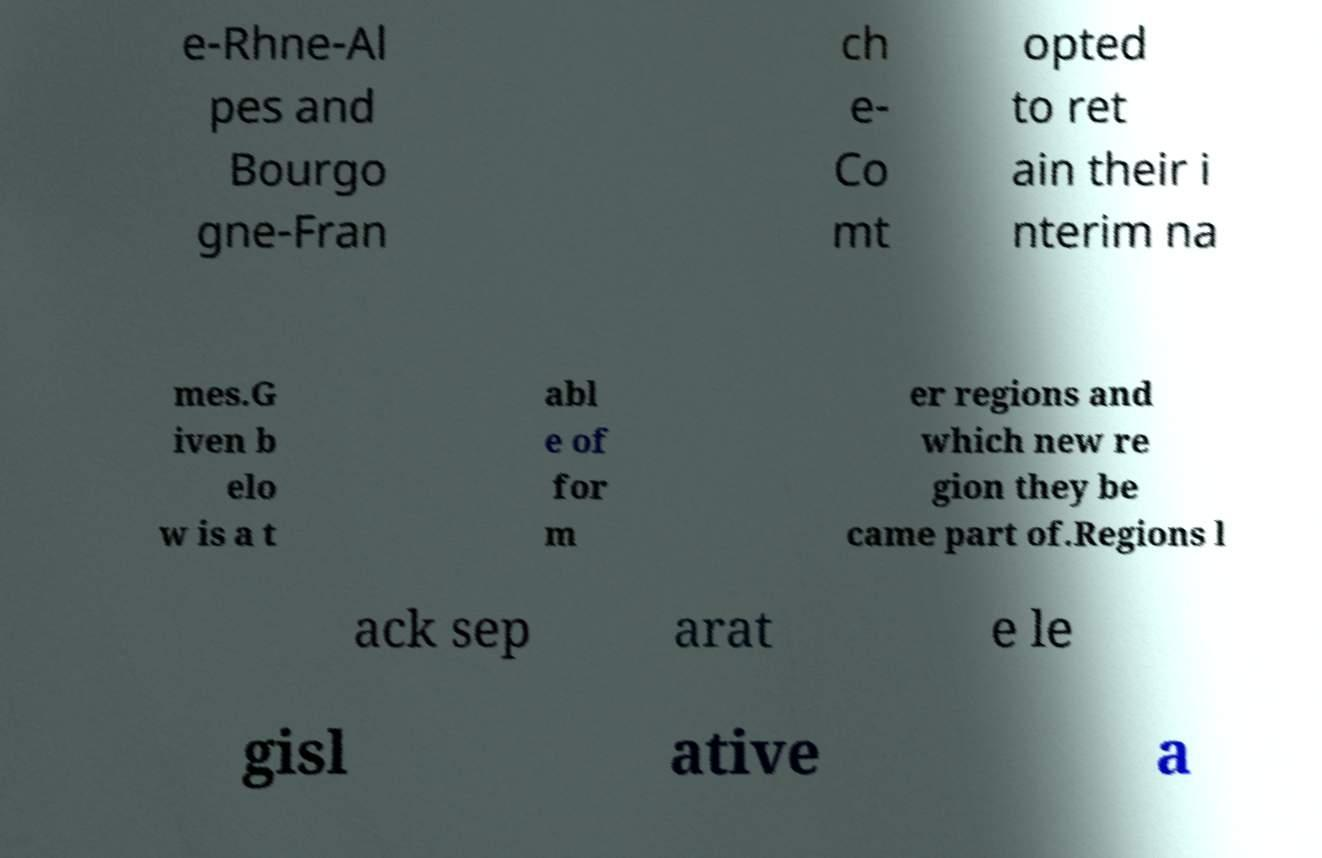There's text embedded in this image that I need extracted. Can you transcribe it verbatim? e-Rhne-Al pes and Bourgo gne-Fran ch e- Co mt opted to ret ain their i nterim na mes.G iven b elo w is a t abl e of for m er regions and which new re gion they be came part of.Regions l ack sep arat e le gisl ative a 